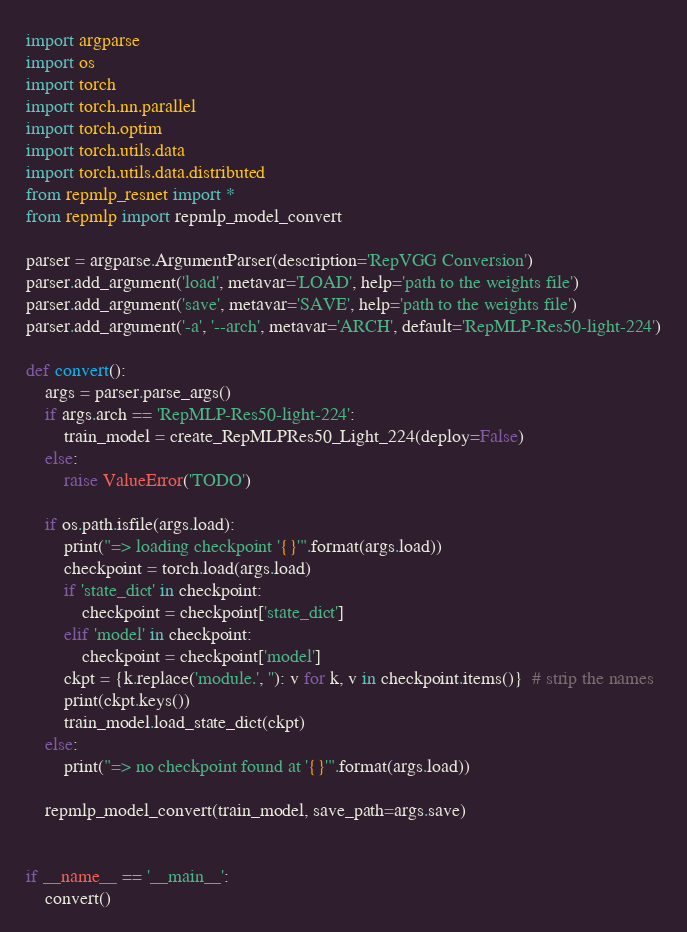Convert code to text. <code><loc_0><loc_0><loc_500><loc_500><_Python_>import argparse
import os
import torch
import torch.nn.parallel
import torch.optim
import torch.utils.data
import torch.utils.data.distributed
from repmlp_resnet import *
from repmlp import repmlp_model_convert

parser = argparse.ArgumentParser(description='RepVGG Conversion')
parser.add_argument('load', metavar='LOAD', help='path to the weights file')
parser.add_argument('save', metavar='SAVE', help='path to the weights file')
parser.add_argument('-a', '--arch', metavar='ARCH', default='RepMLP-Res50-light-224')

def convert():
    args = parser.parse_args()
    if args.arch == 'RepMLP-Res50-light-224':
        train_model = create_RepMLPRes50_Light_224(deploy=False)
    else:
        raise ValueError('TODO')

    if os.path.isfile(args.load):
        print("=> loading checkpoint '{}'".format(args.load))
        checkpoint = torch.load(args.load)
        if 'state_dict' in checkpoint:
            checkpoint = checkpoint['state_dict']
        elif 'model' in checkpoint:
            checkpoint = checkpoint['model']
        ckpt = {k.replace('module.', ''): v for k, v in checkpoint.items()}  # strip the names
        print(ckpt.keys())
        train_model.load_state_dict(ckpt)
    else:
        print("=> no checkpoint found at '{}'".format(args.load))

    repmlp_model_convert(train_model, save_path=args.save)


if __name__ == '__main__':
    convert()</code> 